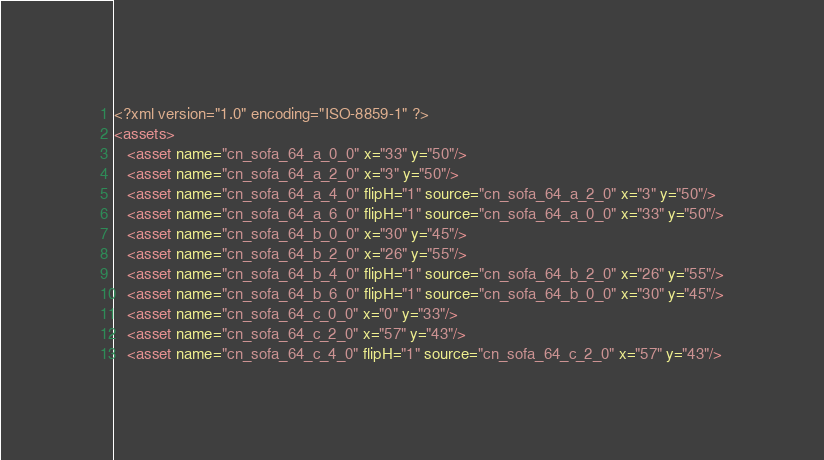<code> <loc_0><loc_0><loc_500><loc_500><_XML_><?xml version="1.0" encoding="ISO-8859-1" ?>
<assets>
   <asset name="cn_sofa_64_a_0_0" x="33" y="50"/>
   <asset name="cn_sofa_64_a_2_0" x="3" y="50"/>
   <asset name="cn_sofa_64_a_4_0" flipH="1" source="cn_sofa_64_a_2_0" x="3" y="50"/>
   <asset name="cn_sofa_64_a_6_0" flipH="1" source="cn_sofa_64_a_0_0" x="33" y="50"/>
   <asset name="cn_sofa_64_b_0_0" x="30" y="45"/>
   <asset name="cn_sofa_64_b_2_0" x="26" y="55"/>
   <asset name="cn_sofa_64_b_4_0" flipH="1" source="cn_sofa_64_b_2_0" x="26" y="55"/>
   <asset name="cn_sofa_64_b_6_0" flipH="1" source="cn_sofa_64_b_0_0" x="30" y="45"/>
   <asset name="cn_sofa_64_c_0_0" x="0" y="33"/>
   <asset name="cn_sofa_64_c_2_0" x="57" y="43"/>
   <asset name="cn_sofa_64_c_4_0" flipH="1" source="cn_sofa_64_c_2_0" x="57" y="43"/></code> 